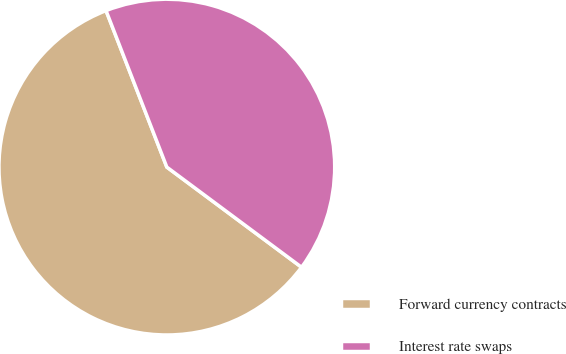Convert chart. <chart><loc_0><loc_0><loc_500><loc_500><pie_chart><fcel>Forward currency contracts<fcel>Interest rate swaps<nl><fcel>58.93%<fcel>41.07%<nl></chart> 